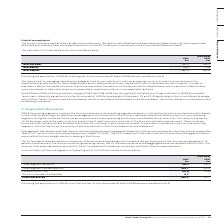According to Auto Trader's financial document, How is net debt calculated? Net debt is calculated as total bank debt and lease financing, less unamortised debt fees and cash and cash equivalents as shown in note 32. The document states: "nsiders capital to be net debt plus total equity. Net debt is calculated as total bank debt and lease financing, less unamortised debt fees and cash a..." Also, What was the amount of borrowings the Group had as at 31 March 2019? borrowings of £313.0m (2018: £343.0m) through its Syndicated revolving credit facility (2018: Syndicated Term Loan).. The document states: "As at 31 March 2019, the Group had borrowings of £313.0m (2018: £343.0m) through its Syndicated revolving credit facility (2018: Syndicated Term Loan)..." Also, What are the components in the table used for the calculation of total capital? The document shows two values: Total net debt and Total equity. From the document: "Total net debt 321.0 355.2 Total equity 59.0 5.6..." Additionally, In which year was total capital larger? According to the financial document, 2019. The relevant text states: "Group plc Annual Report and Financial Statements 2019 | 101..." Also, can you calculate: What was the change in total capital in 2019 from 2018? Based on the calculation: 380.0-360.8, the result is 19.2 (in millions). This is based on the information: "Total capital 380.0 360.8 Total capital 380.0 360.8..." The key data points involved are: 360.8, 380.0. Also, can you calculate: What was the percentage change in total capital in 2019 from 2018? To answer this question, I need to perform calculations using the financial data. The calculation is: (380.0-360.8)/360.8, which equals 5.32 (percentage). This is based on the information: "Total capital 380.0 360.8 Total capital 380.0 360.8..." The key data points involved are: 360.8, 380.0. 